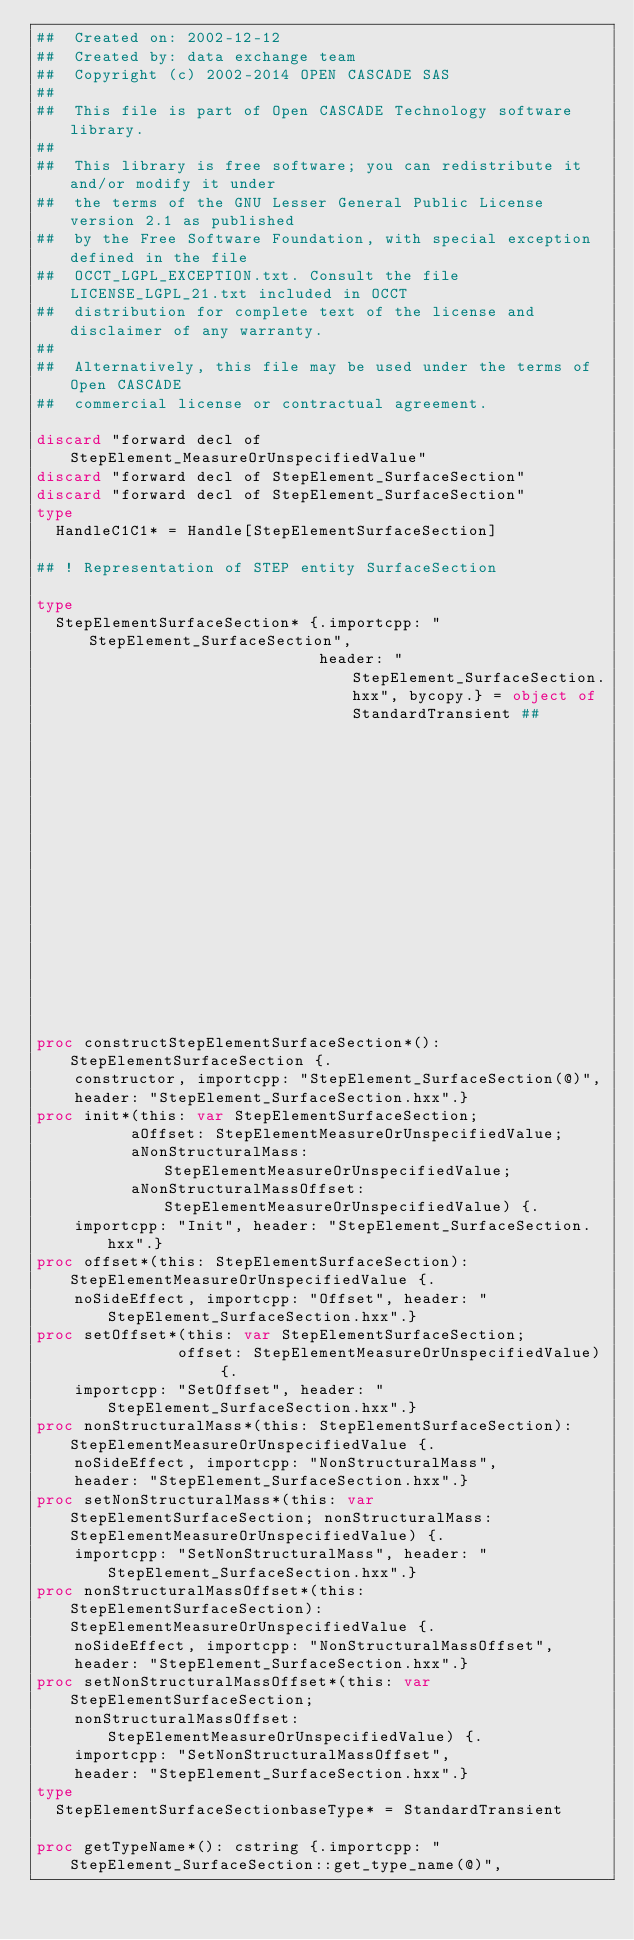Convert code to text. <code><loc_0><loc_0><loc_500><loc_500><_Nim_>##  Created on: 2002-12-12
##  Created by: data exchange team
##  Copyright (c) 2002-2014 OPEN CASCADE SAS
##
##  This file is part of Open CASCADE Technology software library.
##
##  This library is free software; you can redistribute it and/or modify it under
##  the terms of the GNU Lesser General Public License version 2.1 as published
##  by the Free Software Foundation, with special exception defined in the file
##  OCCT_LGPL_EXCEPTION.txt. Consult the file LICENSE_LGPL_21.txt included in OCCT
##  distribution for complete text of the license and disclaimer of any warranty.
##
##  Alternatively, this file may be used under the terms of Open CASCADE
##  commercial license or contractual agreement.

discard "forward decl of StepElement_MeasureOrUnspecifiedValue"
discard "forward decl of StepElement_SurfaceSection"
discard "forward decl of StepElement_SurfaceSection"
type
  HandleC1C1* = Handle[StepElementSurfaceSection]

## ! Representation of STEP entity SurfaceSection

type
  StepElementSurfaceSection* {.importcpp: "StepElement_SurfaceSection",
                              header: "StepElement_SurfaceSection.hxx", bycopy.} = object of StandardTransient ##
                                                                                                        ## !
                                                                                                        ## Empty
                                                                                                        ## constructor


proc constructStepElementSurfaceSection*(): StepElementSurfaceSection {.
    constructor, importcpp: "StepElement_SurfaceSection(@)",
    header: "StepElement_SurfaceSection.hxx".}
proc init*(this: var StepElementSurfaceSection;
          aOffset: StepElementMeasureOrUnspecifiedValue;
          aNonStructuralMass: StepElementMeasureOrUnspecifiedValue;
          aNonStructuralMassOffset: StepElementMeasureOrUnspecifiedValue) {.
    importcpp: "Init", header: "StepElement_SurfaceSection.hxx".}
proc offset*(this: StepElementSurfaceSection): StepElementMeasureOrUnspecifiedValue {.
    noSideEffect, importcpp: "Offset", header: "StepElement_SurfaceSection.hxx".}
proc setOffset*(this: var StepElementSurfaceSection;
               offset: StepElementMeasureOrUnspecifiedValue) {.
    importcpp: "SetOffset", header: "StepElement_SurfaceSection.hxx".}
proc nonStructuralMass*(this: StepElementSurfaceSection): StepElementMeasureOrUnspecifiedValue {.
    noSideEffect, importcpp: "NonStructuralMass",
    header: "StepElement_SurfaceSection.hxx".}
proc setNonStructuralMass*(this: var StepElementSurfaceSection; nonStructuralMass: StepElementMeasureOrUnspecifiedValue) {.
    importcpp: "SetNonStructuralMass", header: "StepElement_SurfaceSection.hxx".}
proc nonStructuralMassOffset*(this: StepElementSurfaceSection): StepElementMeasureOrUnspecifiedValue {.
    noSideEffect, importcpp: "NonStructuralMassOffset",
    header: "StepElement_SurfaceSection.hxx".}
proc setNonStructuralMassOffset*(this: var StepElementSurfaceSection;
    nonStructuralMassOffset: StepElementMeasureOrUnspecifiedValue) {.
    importcpp: "SetNonStructuralMassOffset",
    header: "StepElement_SurfaceSection.hxx".}
type
  StepElementSurfaceSectionbaseType* = StandardTransient

proc getTypeName*(): cstring {.importcpp: "StepElement_SurfaceSection::get_type_name(@)",</code> 